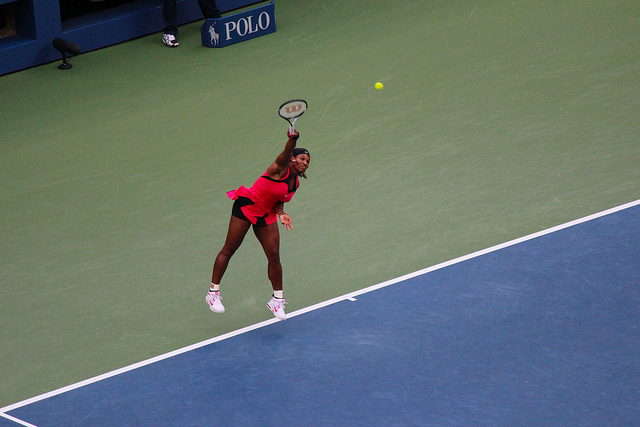<image>Where is the shadow? It is ambiguous where the shadow is. It's not visible but it could be on the ground, under or behind something. Who is winning? It is ambiguous who is winning. It could be the woman in red, the red team or Serena Williams. Where is the shadow? I don't know where the shadow is. It can be on the ground, under something, or behind something. Who is winning? I don't know who is winning. It can be either the red team or Serena Williams. 